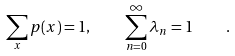<formula> <loc_0><loc_0><loc_500><loc_500>\sum _ { x } p ( x ) = 1 , \quad \sum _ { n = 0 } ^ { \infty } \lambda _ { n } = 1 \quad .</formula> 